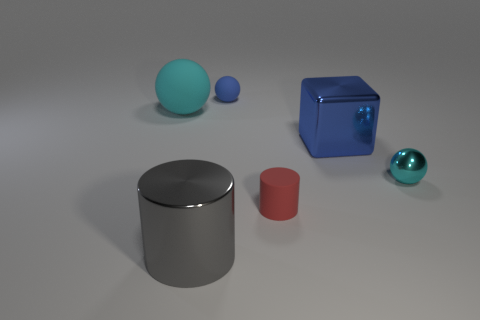Does the cyan ball to the right of the gray metallic cylinder have the same size as the big block?
Your answer should be compact. No. What is the size of the metal object that is left of the small metal thing and behind the red rubber cylinder?
Provide a succinct answer. Large. There is another sphere that is the same color as the big matte ball; what is its material?
Your response must be concise. Metal. What number of big balls are the same color as the large metal cylinder?
Make the answer very short. 0. Are there an equal number of large gray things that are on the right side of the red cylinder and tiny matte cubes?
Keep it short and to the point. Yes. What color is the large metal cylinder?
Provide a succinct answer. Gray. What size is the cyan object that is the same material as the blue block?
Ensure brevity in your answer.  Small. The small thing that is the same material as the large blue block is what color?
Provide a succinct answer. Cyan. Is there another metal sphere of the same size as the cyan shiny sphere?
Provide a succinct answer. No. What is the material of the tiny blue object that is the same shape as the small cyan thing?
Your answer should be very brief. Rubber. 